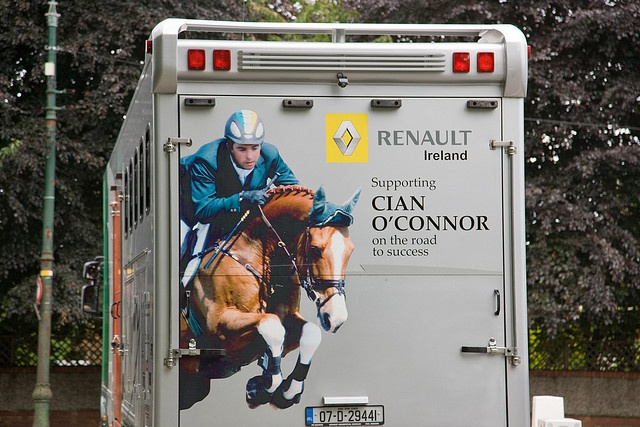Describe the objects in this image and their specific colors. I can see truck in black, darkgray, lightgray, and gray tones, horse in black, maroon, lightgray, and tan tones, and people in black, teal, blue, and navy tones in this image. 